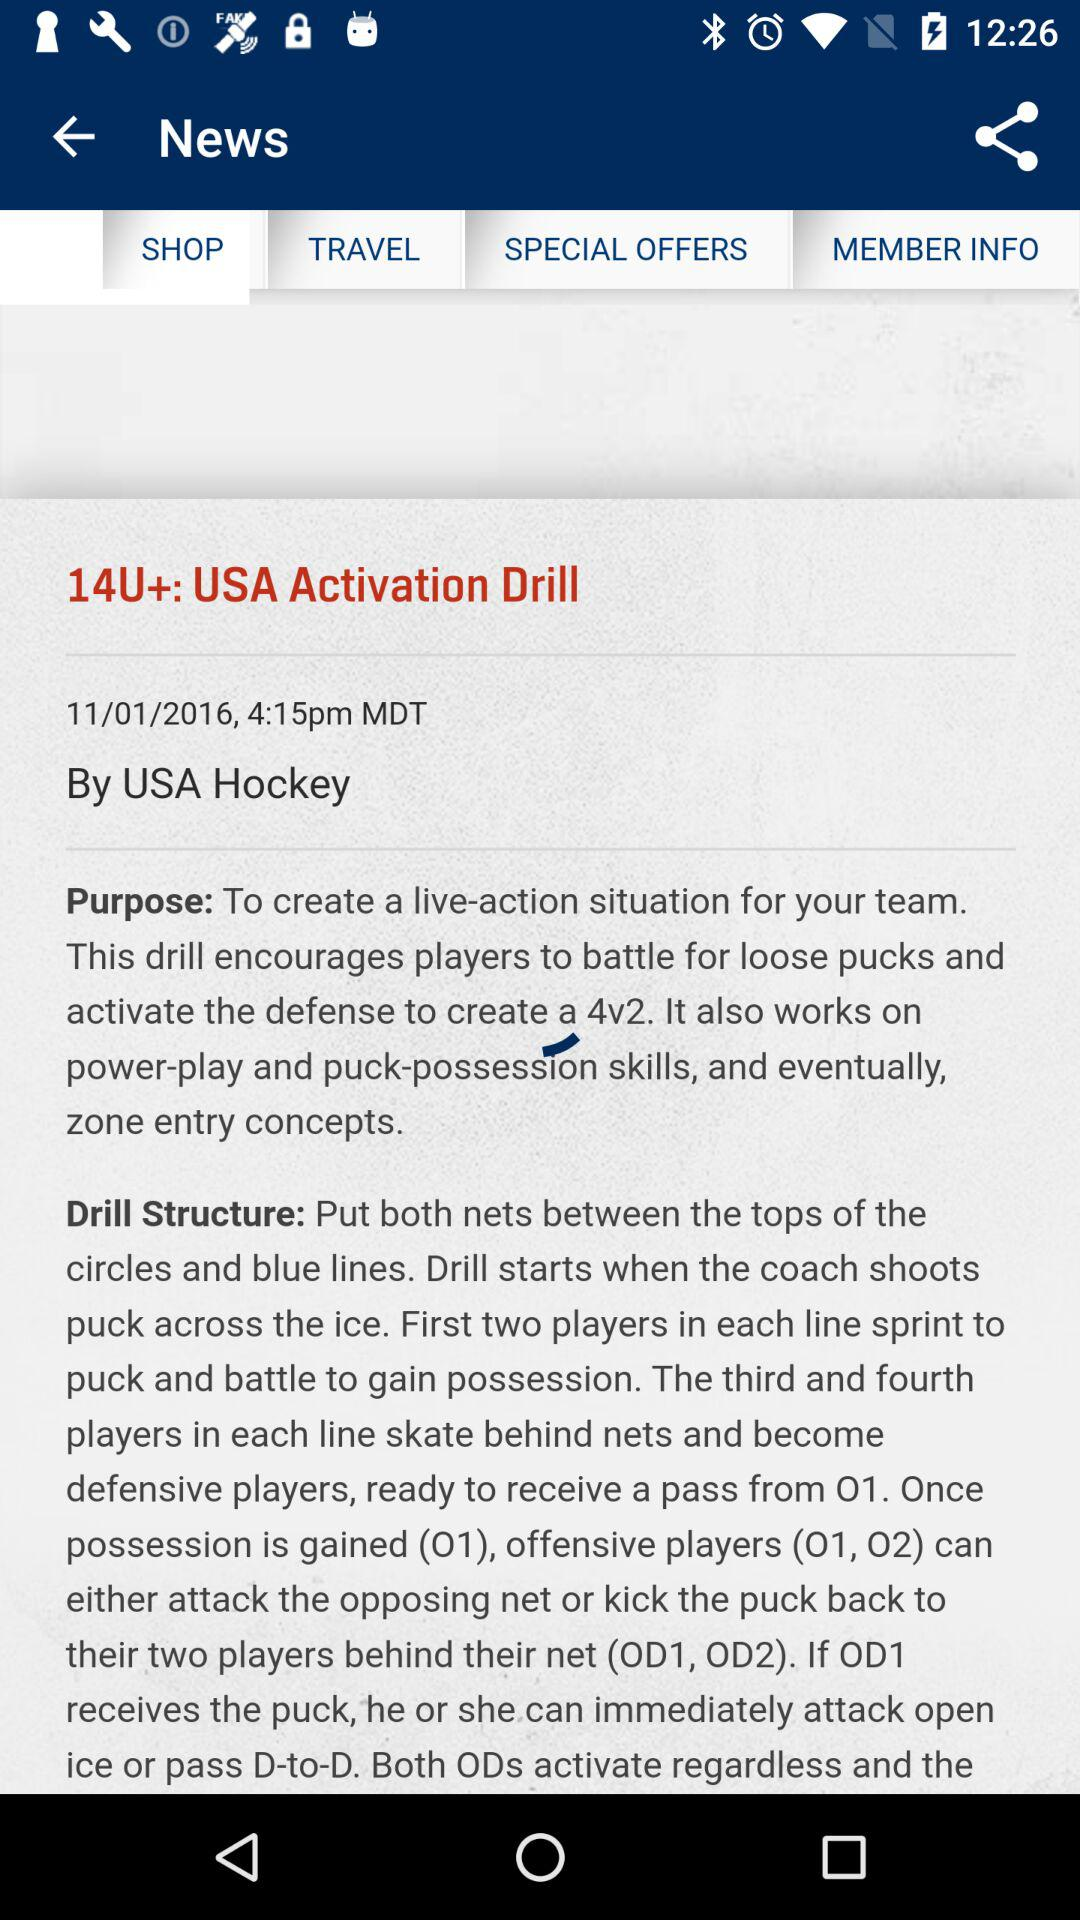At what time is the news "USA Activation Drill" posted? The time is 4:15pm. 